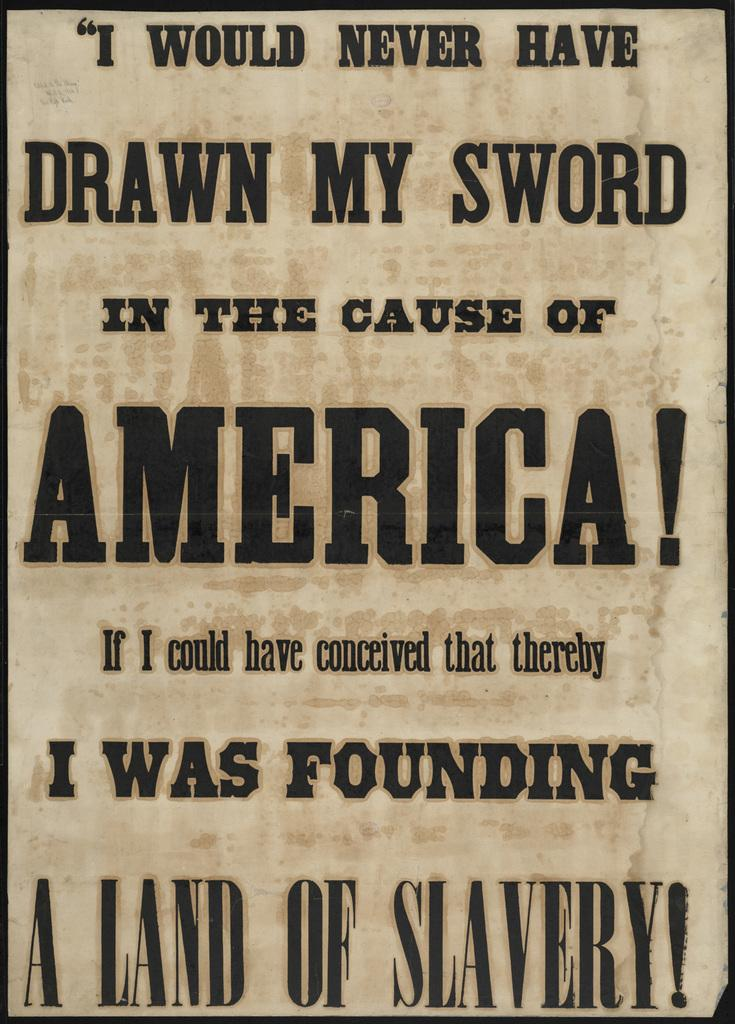<image>
Write a terse but informative summary of the picture. A beige and black poster talking of America and slavery. 